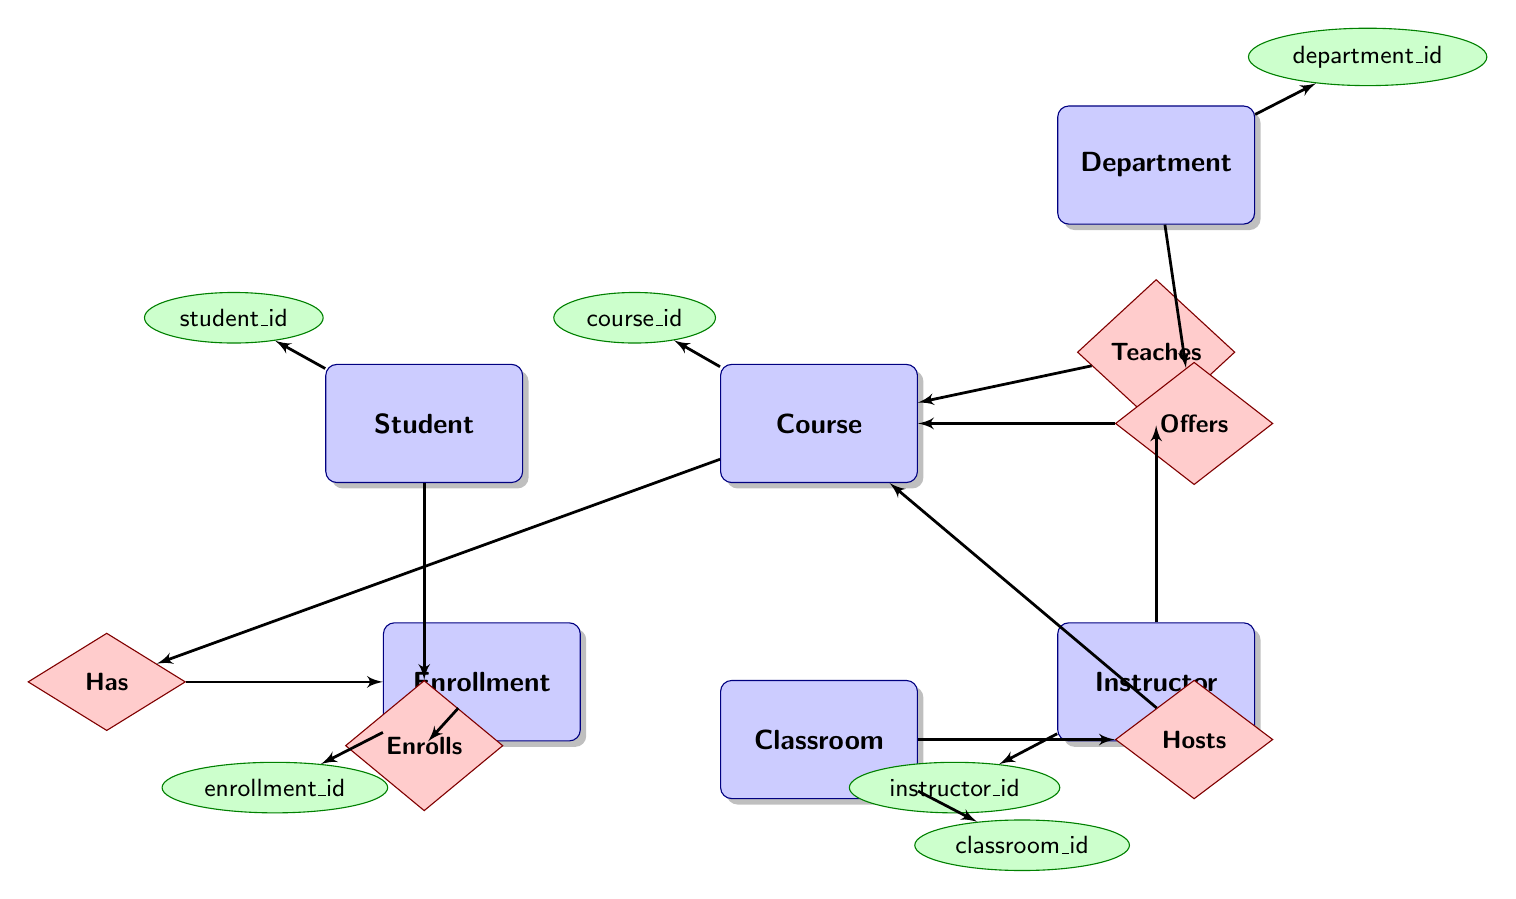What is the primary key for the Student entity? The primary key is identified in the diagram as the unique identifier for the Student entity, which is "student_id." It is shown in the diagram as an attribute linked to the Student entity.
Answer: student_id How many entities are shown in the diagram? The diagram includes six entities: Student, Course, Instructor, Enrollment, Department, and Classroom. By counting each of these entities, we determine that there are six entities in total.
Answer: 6 What relationship exists between Course and Enrollment? The diagram depicts a "Has" relationship between Course and Enrollment, indicating that each Course can have multiple enrollments associated with it. This shows that Enrollment is connected to Course through this relationship.
Answer: Has Which entity is related to the Department entity? The Course entity is the one related to the Department entity through the relationship "Offers." This relationship indicates that a Department can offer multiple Courses, linking the two entities.
Answer: Course How many relationships are there between entities in the diagram? The diagram depicts five relationships: Student_Enrollment, Course_Enrollment, Instructor_Course, Department_Course, and Classroom_Course. By counting these, we find there are five distinct relationships shown in the diagram.
Answer: 5 Which attribute is common between Enrollment and Student? The common attribute between Enrollment and Student is "student_id." This attribute serves as a foreign key in the Enrollment entity, linking it to the Student entity, thus indicating which student is enrolled.
Answer: student_id What type of relationship is formed between Instructor and Course? The diagram illustrates a "Teaches" relationship between Instructor and Course, indicating that each Instructor can teach multiple Courses. This is a one-to-many relationship, demonstrating the connection between the two entities.
Answer: Teaches Which entities have a one-to-many relationship with Course? The entities that have a one-to-many relationship with Course are Enrollment, Instructor, Department, and Classroom. Each of these entities is connected to Course, showing that multiple instances from each can relate to one Course.
Answer: Enrollment, Instructor, Department, Classroom 